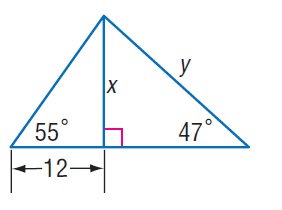Question: Find x.
Choices:
A. 17.1
B. 18.9
C. 21.2
D. 32.3
Answer with the letter. Answer: A 